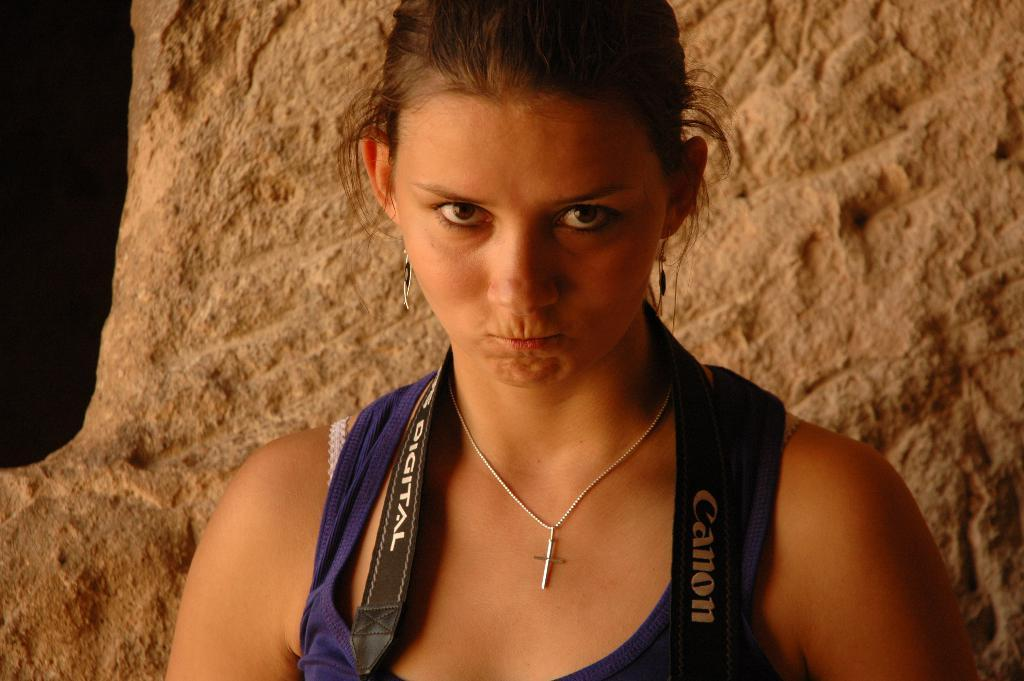What is the main subject of the image? There is a person in the image. Can you describe the background of the image? There is a rock in the background of the image. Is there a mailbox visible in the image? There is no mention of a mailbox in the provided facts, so it cannot be determined if one is present in the image. What type of nose does the person in the image have? The provided facts do not mention the person's nose, so it cannot be determined from the image. 